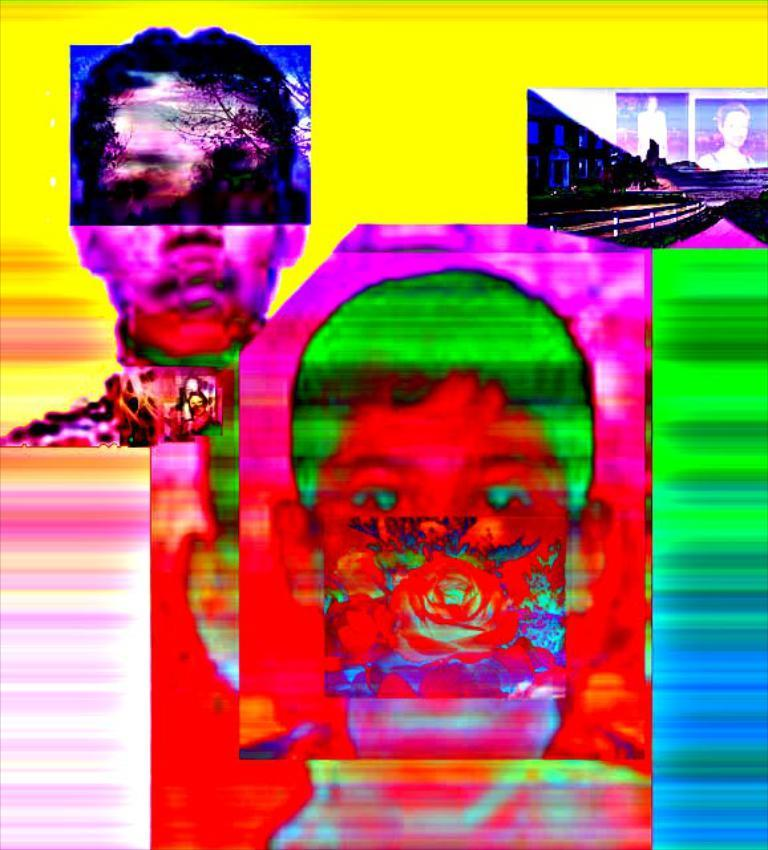How many people are in the image? There are persons in the image, but the exact number is not specified. Can you describe the background of the image? The background of the image has different colors. What type of engine is visible in the image? There is no engine present in the image. Who sits on the throne in the image? There is no throne present in the image. 